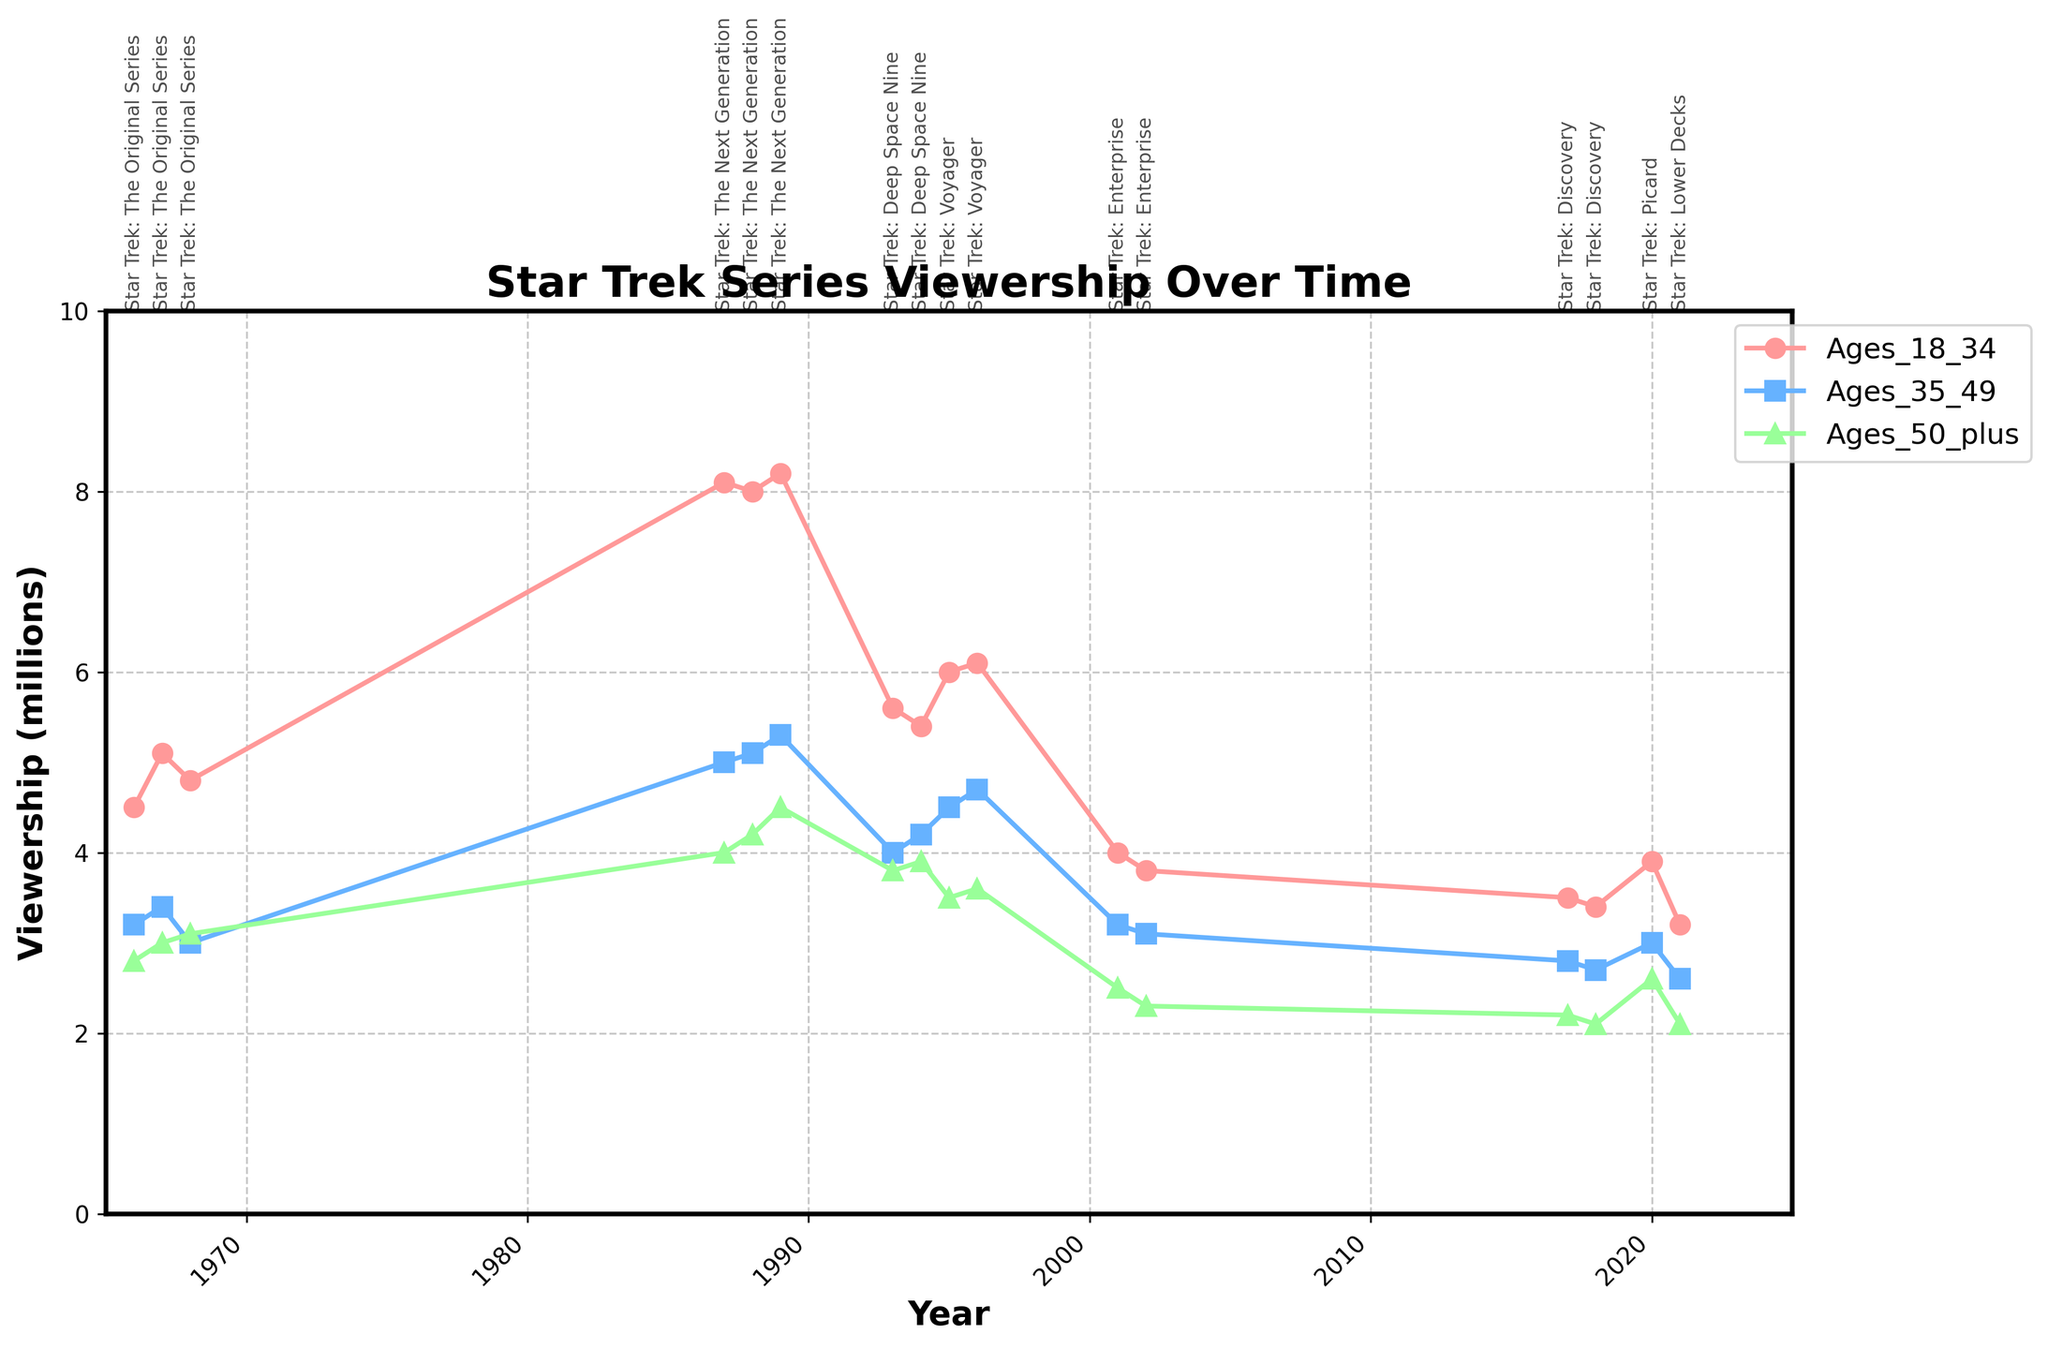How many Star Trek series are shown in the plot? Count the unique series names annotated on the plot. There are six: "Star Trek: The Original Series," "Star Trek: The Next Generation," "Star Trek: Deep Space Nine," "Star Trek: Voyager," "Star Trek: Enterprise," "Star Trek: Discovery," "Star Trek: Picard," and "Star Trek: Lower Decks."
Answer: 8 Which age group had the highest viewership for "Star Trek: The Next Generation" in 1987? Look at the three age group lines for the year 1987 and note the highest value. The "Viewership_Ages_18_34" line is the highest at 8.1 million viewers.
Answer: Viewership_Ages_18_34 What is the title of the plot? Read the title displayed at the top of the plot. It states "Star Trek Series Viewership Over Time."
Answer: Star Trek Series Viewership Over Time Between 2001 and 2002, for which age group did viewership decline the most for "Star Trek: Enterprise"? Compare the viewership values from 2001 to 2002 for each age group. The viewership for "Viewership_Ages_18_34" decreased from 4.0 to 3.8, for "Viewership_Ages_35_49" from 3.2 to 3.1, and for "Viewership_Ages_50_plus" from 2.5 to 2.3. The largest decline is 0.2 million viewers in the "Viewership_Ages_18_34" group.
Answer: Viewership_Ages_18_34 Which series had the lowest viewership in the "Viewership_Ages_35_49" group and in which year? Locate the minimum point on the "Viewership_Ages_35_49" line and check the corresponding series and year. The lowest viewership is in 2002 with 3.1 million viewers for "Star Trek: Enterprise."
Answer: Star Trek: Enterprise in 2002 Which age group had the most stable viewership trends over time? Evaluate the smoothness or small range of fluctuations among the three age group lines. "Viewership_Ages_50_plus" shows relatively stable trends compared to the others.
Answer: Viewership_Ages_50_plus From the plot, which Star Trek series saw the highest initial viewership in its debut year and for which age group? Compare initial viewership values for each series' debut year across age groups. "Star Trek: The Next Generation" in 1987 had the highest initial viewership with 8.1 million viewers in the "Viewership_Ages_18_34" group.
Answer: Star Trek: The Next Generation in 1987, Viewership_Ages_18_34 